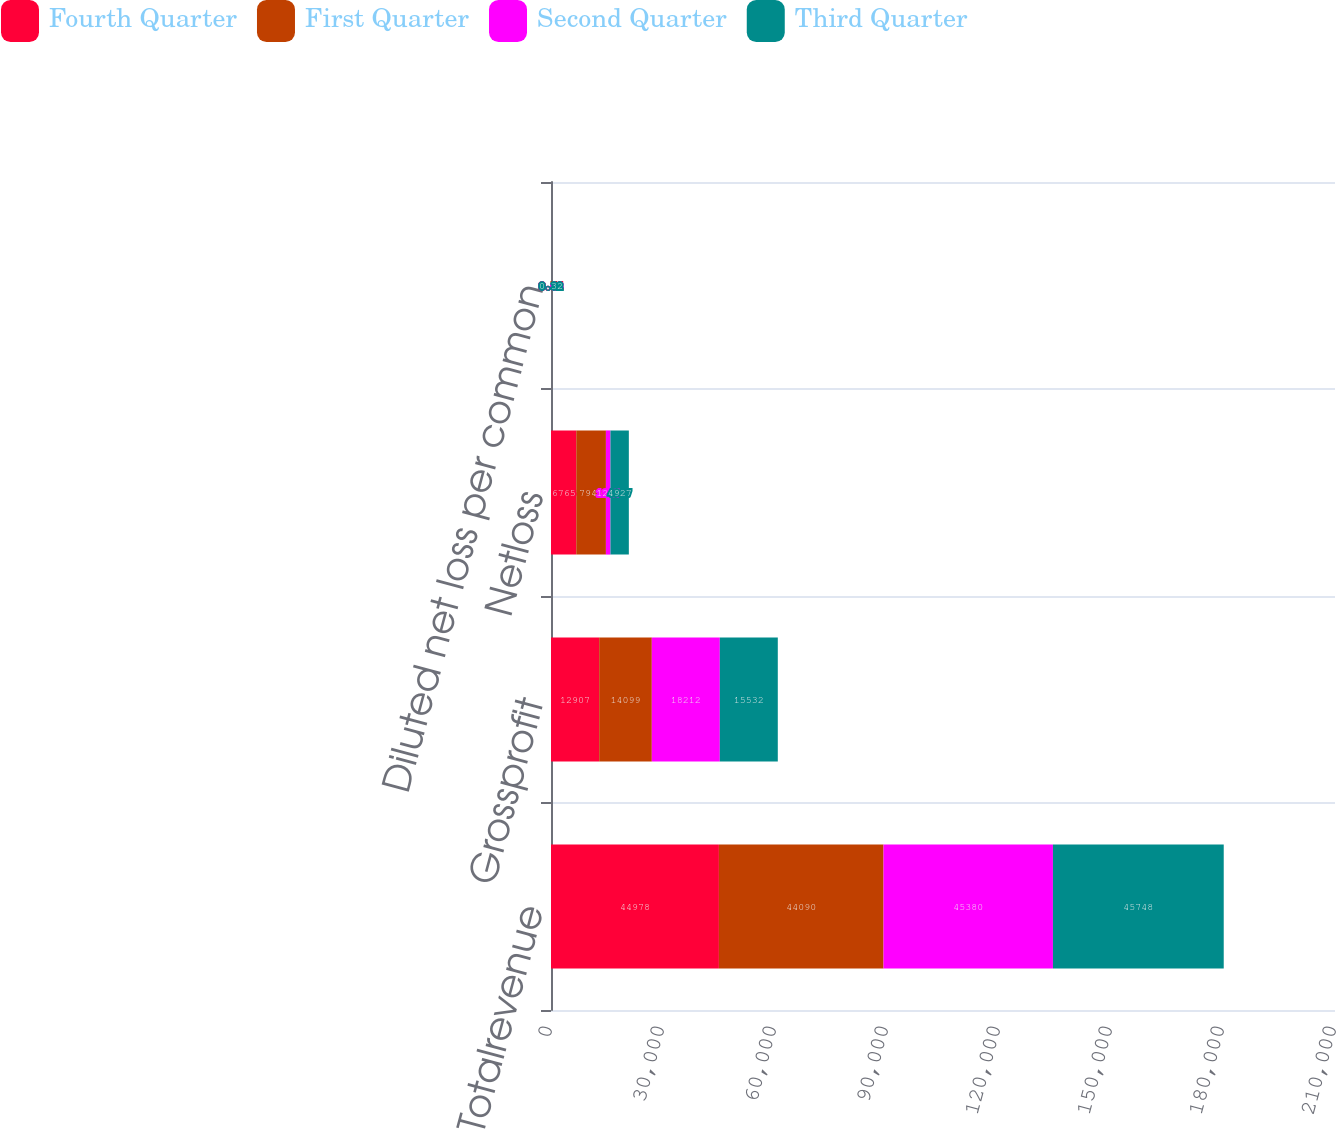Convert chart to OTSL. <chart><loc_0><loc_0><loc_500><loc_500><stacked_bar_chart><ecel><fcel>Totalrevenue<fcel>Grossprofit<fcel>Netloss<fcel>Diluted net loss per common<nl><fcel>Fourth Quarter<fcel>44978<fcel>12907<fcel>6765<fcel>0.44<nl><fcel>First Quarter<fcel>44090<fcel>14099<fcel>7945<fcel>0.51<nl><fcel>Second Quarter<fcel>45380<fcel>18212<fcel>1213<fcel>0.08<nl><fcel>Third Quarter<fcel>45748<fcel>15532<fcel>4927<fcel>0.32<nl></chart> 